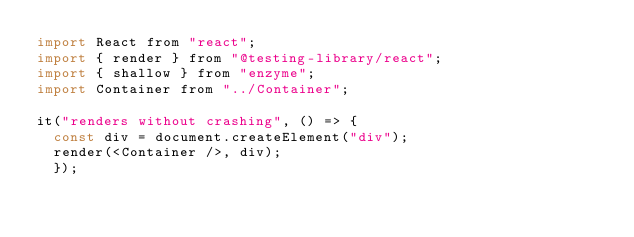Convert code to text. <code><loc_0><loc_0><loc_500><loc_500><_JavaScript_>import React from "react";
import { render } from "@testing-library/react";
import { shallow } from "enzyme";
import Container from "../Container";

it("renders without crashing", () => {
  const div = document.createElement("div");
  render(<Container />, div);
  });
</code> 